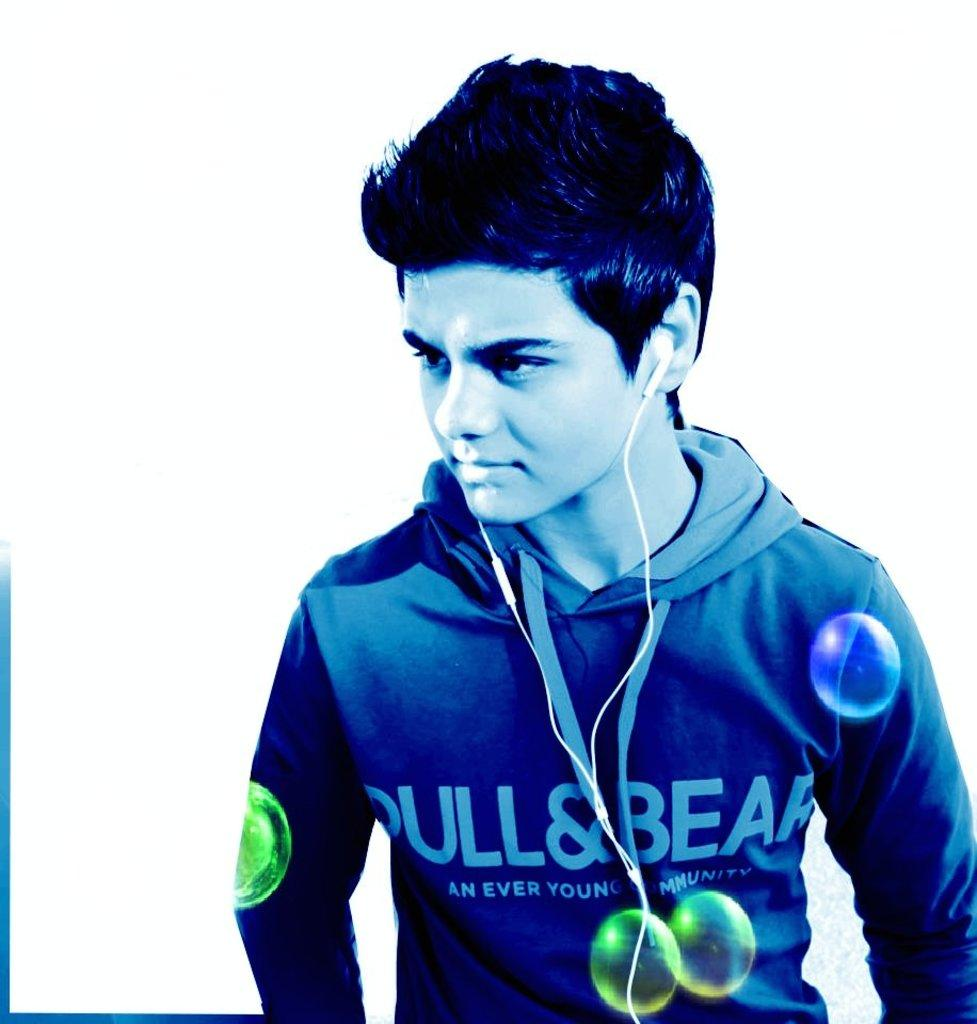Who is present in the image? There is a man in the image. What is the man wearing? The man is wearing a blue jacket. What is the man doing in the image? The man is standing. What is the man wearing in his ears? The man has earphones in his ears. What color is the background of the image? The background of the image is white in color. How many pigs are visible in the image? There are no pigs present in the image. What type of division is being performed by the man in the image? The man is not performing any division in the image; he is simply standing with earphones in his ears. 